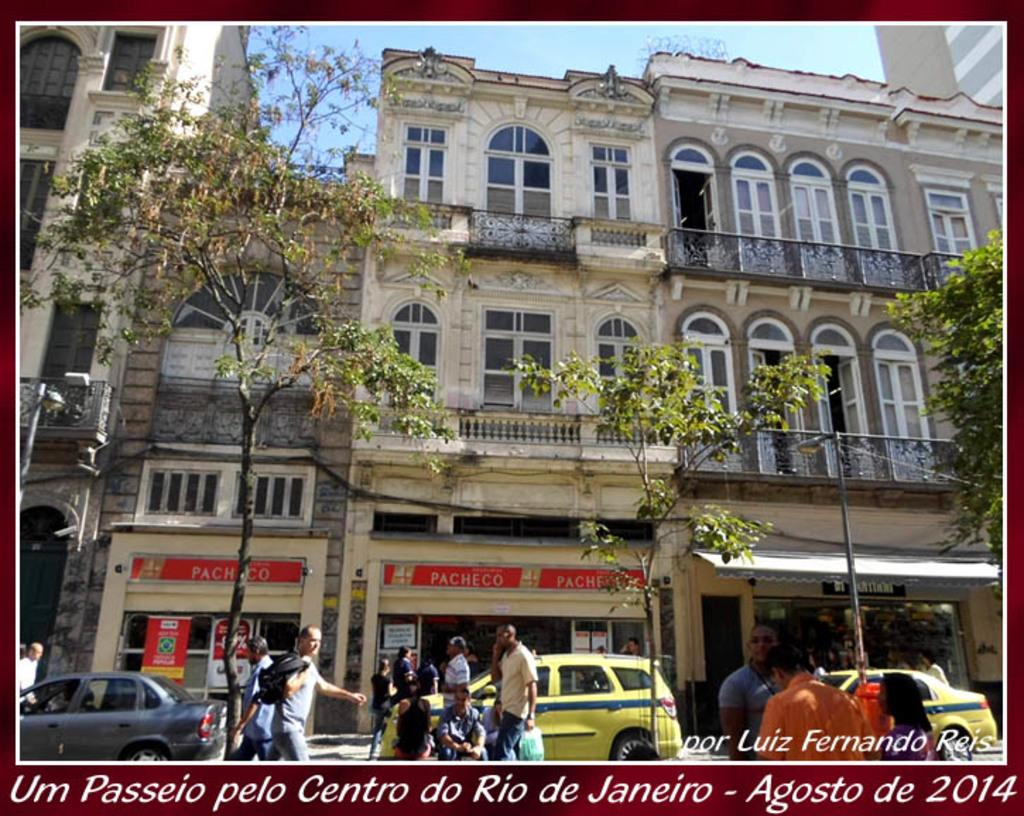<image>
Give a short and clear explanation of the subsequent image. A scene from Rio de Janeiro in August 2014. 